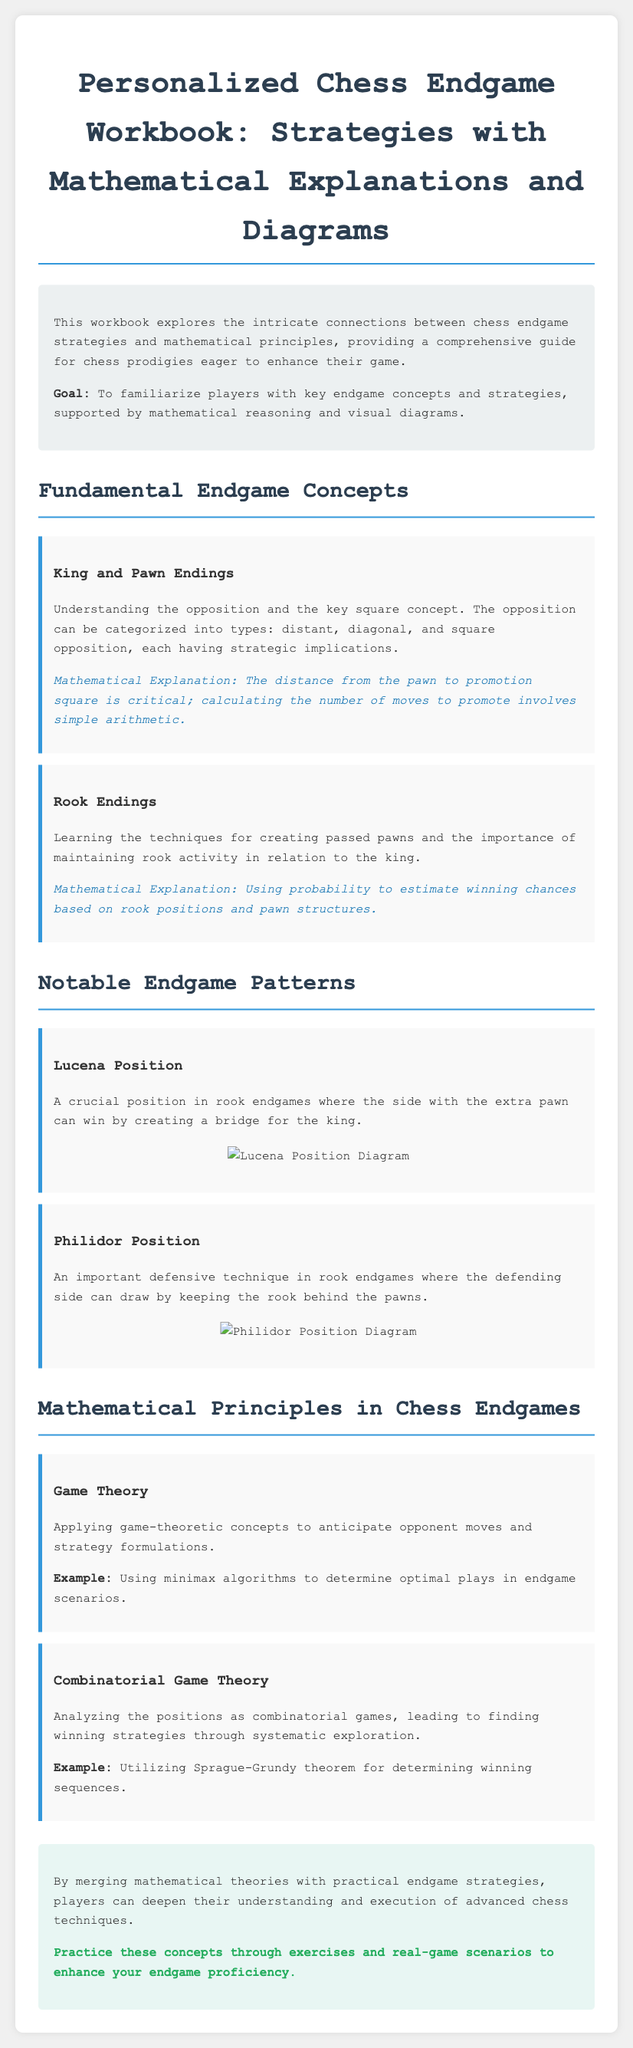What is the title of the workbook? The title of the workbook is prominently displayed at the top of the document.
Answer: Personalized Chess Endgame Workbook: Strategies with Mathematical Explanations and Diagrams What is the primary goal of the workbook? The primary goal is outlined in the introduction section of the document.
Answer: To familiarize players with key endgame concepts and strategies, supported by mathematical reasoning and visual diagrams What are the two types of endgames discussed? The document specifies two distinct types of endgames in the fundamental concepts section.
Answer: King and Pawn Endings, Rook Endings What is the significant position mentioned in rook endgames? The Lucena Position is specifically mentioned as crucial in rook endgames.
Answer: Lucena Position What mathematical concept is applied to anticipate opponent moves? The document refers to a specific mathematical concept related to opponent strategy in chess.
Answer: Game Theory What theorem is mentioned for determining winning sequences? The Sprague-Grundy theorem is cited as a method for finding winning strategies.
Answer: Sprague-Grundy theorem What is the nature of the visual aids provided in the document? The document describes diagrams that illustrate key positions and concepts in chess.
Answer: Diagrams What is emphasized for enhancing endgame proficiency? The conclusion highlights a particular method for improving endgame skills.
Answer: Practice through exercises and real-game scenarios 